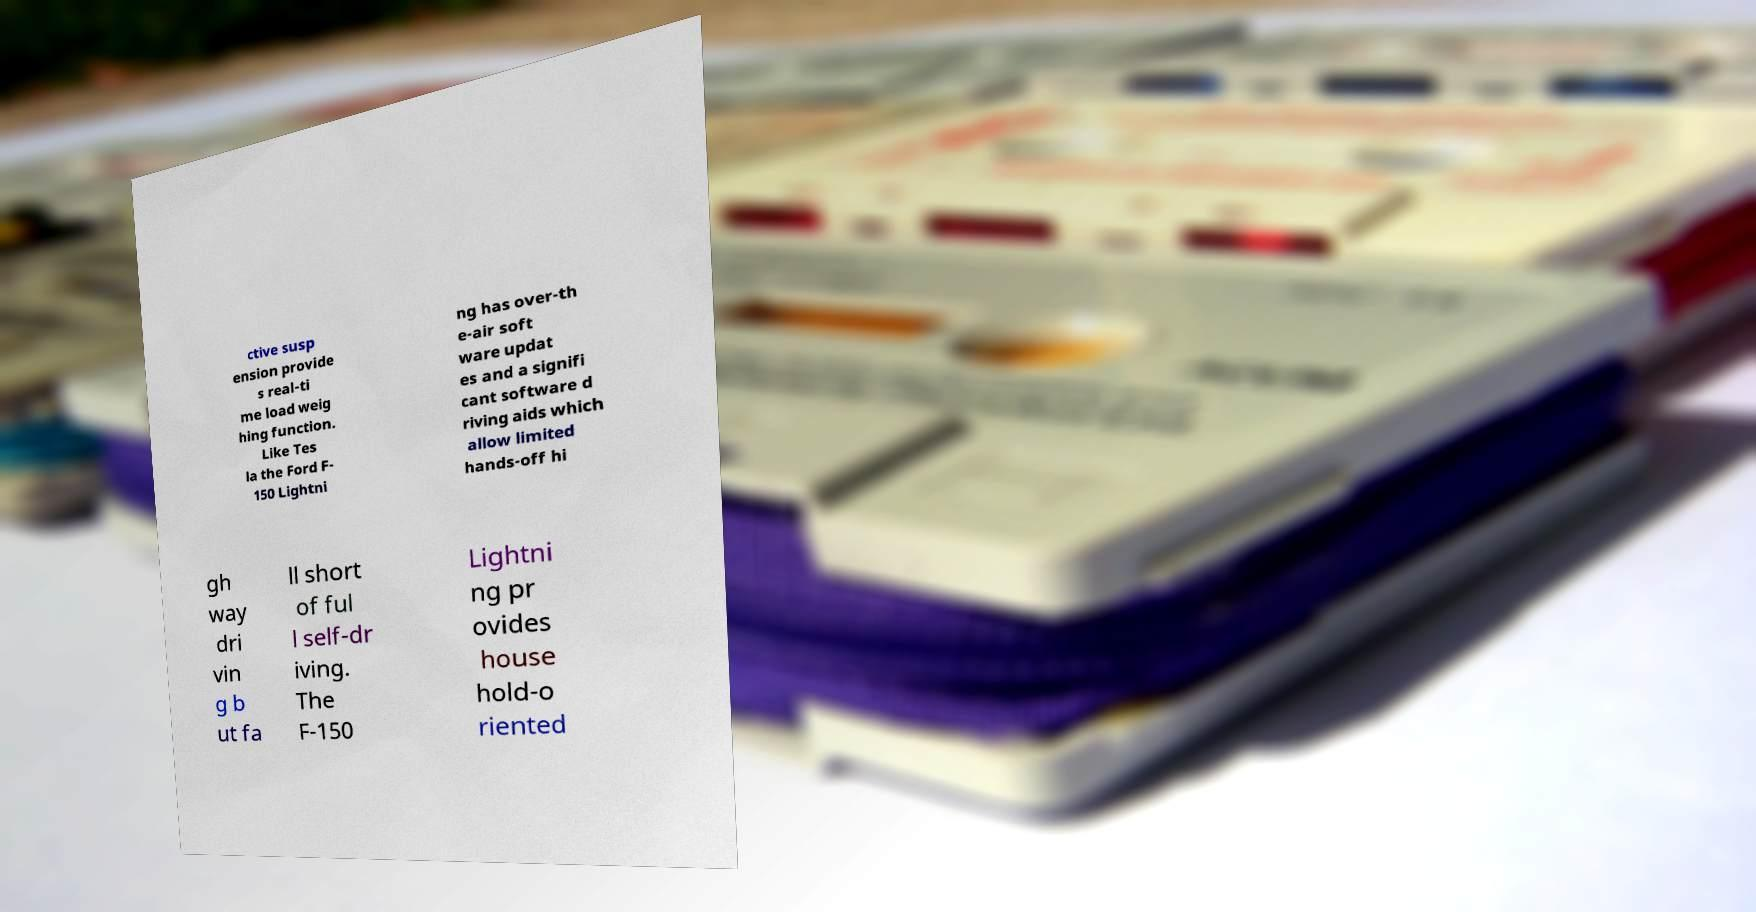Could you assist in decoding the text presented in this image and type it out clearly? ctive susp ension provide s real-ti me load weig hing function. Like Tes la the Ford F- 150 Lightni ng has over-th e-air soft ware updat es and a signifi cant software d riving aids which allow limited hands-off hi gh way dri vin g b ut fa ll short of ful l self-dr iving. The F-150 Lightni ng pr ovides house hold-o riented 